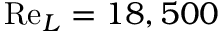Convert formula to latex. <formula><loc_0><loc_0><loc_500><loc_500>R e _ { L } = 1 8 , 5 0 0</formula> 